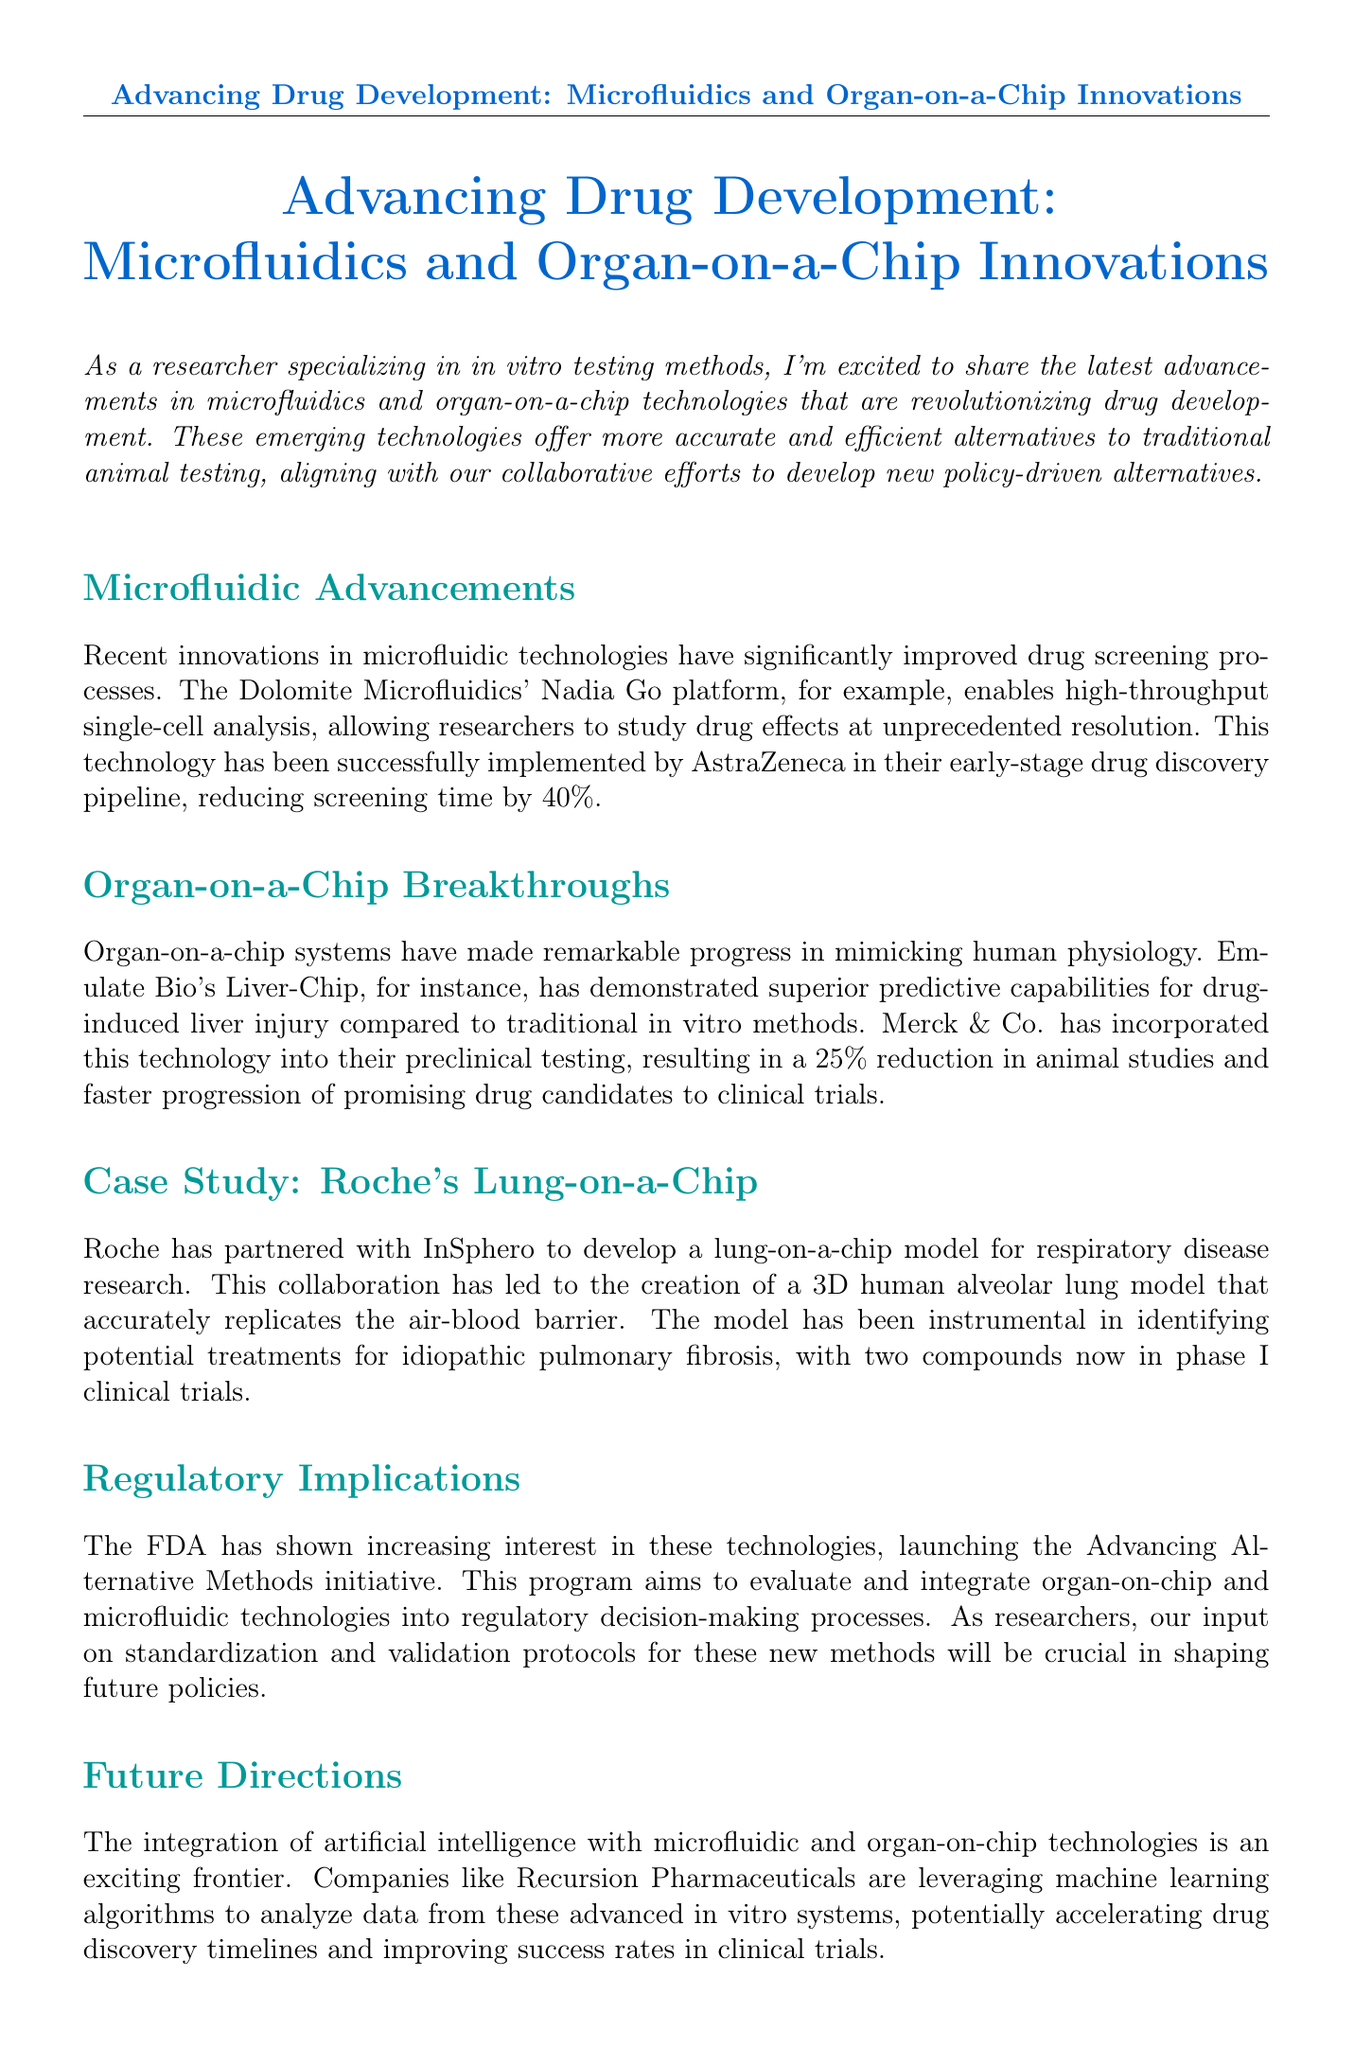What technology does Dolomite Microfluidics offer? The Dolomite Microfluidics' Nadia Go platform enables high-throughput single-cell analysis.
Answer: Nadia Go platform How much did AstraZeneca reduce their screening time by? AstraZeneca reduced screening time by 40% using the technology mentioned in the document.
Answer: 40% What percentage of animal studies did Merck & Co. reduce with the Liver-Chip? Merck & Co. achieved a 25% reduction in animal studies through the use of the Liver-Chip technology.
Answer: 25% Which respiratory disease is Roche's lung-on-a-chip model focused on? The lung-on-a-chip model developed by Roche is aimed at researching idiopathic pulmonary fibrosis.
Answer: idiopathic pulmonary fibrosis What is the name of the FDA initiative mentioned in the document? The initiative launched by the FDA to evaluate these new technologies is called Advancing Alternative Methods.
Answer: Advancing Alternative Methods Which company is integrating artificial intelligence with these technologies? Recursion Pharmaceuticals is leveraging machine learning algorithms with microfluidic and organ-on-chip technologies.
Answer: Recursion Pharmaceuticals What kind of model did Roche collaborate with InSphero to develop? Roche collaborated to develop a lung-on-a-chip model.
Answer: lung-on-a-chip model What impact do emerging technologies have on drug development methods? The document states these technologies represent a step forward for more ethical, efficient, and predictive drug development methods.
Answer: more ethical, efficient, and predictive 